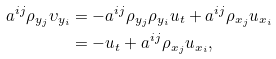<formula> <loc_0><loc_0><loc_500><loc_500>a ^ { i j } \rho _ { y _ { j } } \upsilon _ { y _ { i } } & = - a ^ { i j } \rho _ { y _ { j } } \rho _ { y _ { i } } u _ { t } + a ^ { i j } \rho _ { x _ { j } } u _ { x _ { i } } \\ & = - u _ { t } + a ^ { i j } \rho _ { x _ { j } } u _ { x _ { i } } ,</formula> 